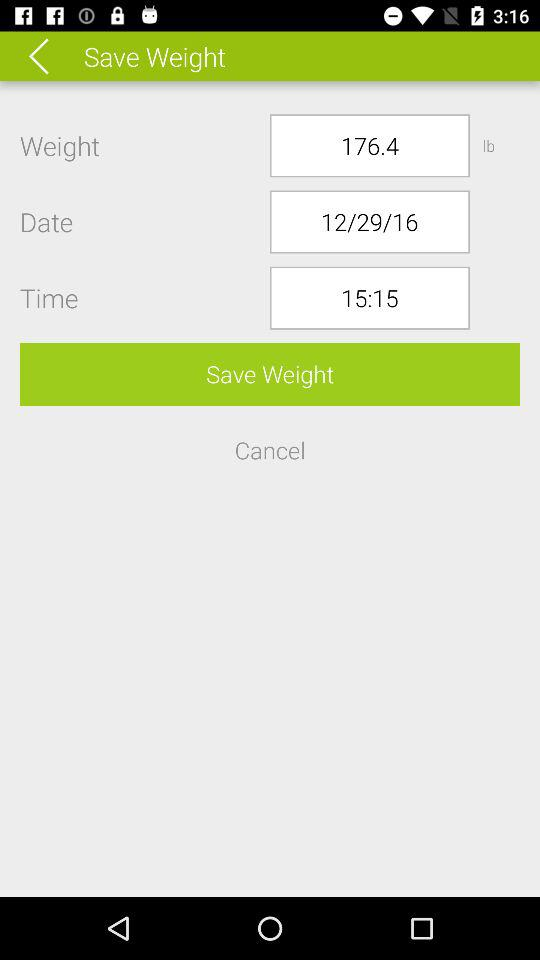What is the selected date? The selected date is December 29, 2016. 